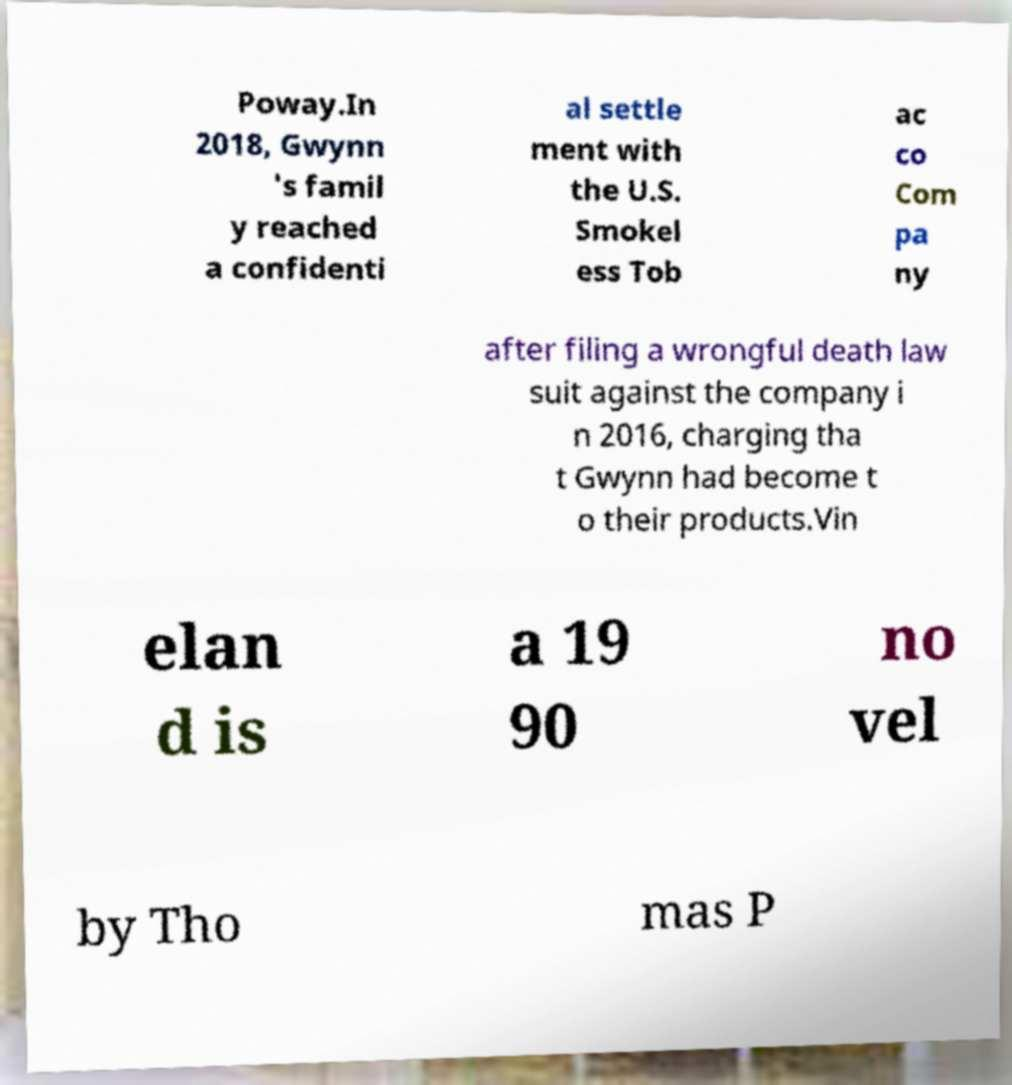Can you read and provide the text displayed in the image?This photo seems to have some interesting text. Can you extract and type it out for me? Poway.In 2018, Gwynn 's famil y reached a confidenti al settle ment with the U.S. Smokel ess Tob ac co Com pa ny after filing a wrongful death law suit against the company i n 2016, charging tha t Gwynn had become t o their products.Vin elan d is a 19 90 no vel by Tho mas P 